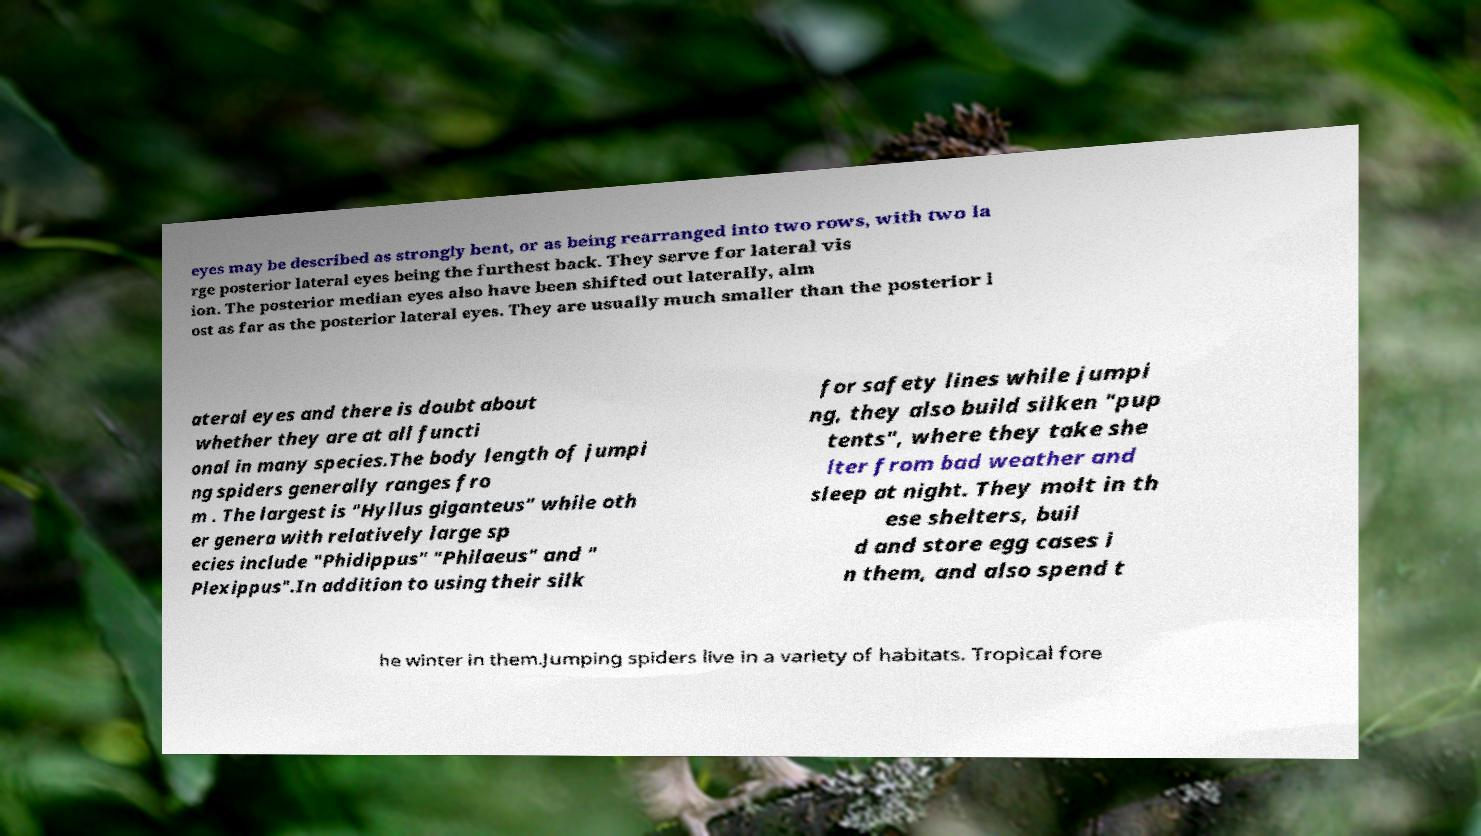Could you assist in decoding the text presented in this image and type it out clearly? eyes may be described as strongly bent, or as being rearranged into two rows, with two la rge posterior lateral eyes being the furthest back. They serve for lateral vis ion. The posterior median eyes also have been shifted out laterally, alm ost as far as the posterior lateral eyes. They are usually much smaller than the posterior l ateral eyes and there is doubt about whether they are at all functi onal in many species.The body length of jumpi ng spiders generally ranges fro m . The largest is "Hyllus giganteus" while oth er genera with relatively large sp ecies include "Phidippus" "Philaeus" and " Plexippus".In addition to using their silk for safety lines while jumpi ng, they also build silken "pup tents", where they take she lter from bad weather and sleep at night. They molt in th ese shelters, buil d and store egg cases i n them, and also spend t he winter in them.Jumping spiders live in a variety of habitats. Tropical fore 